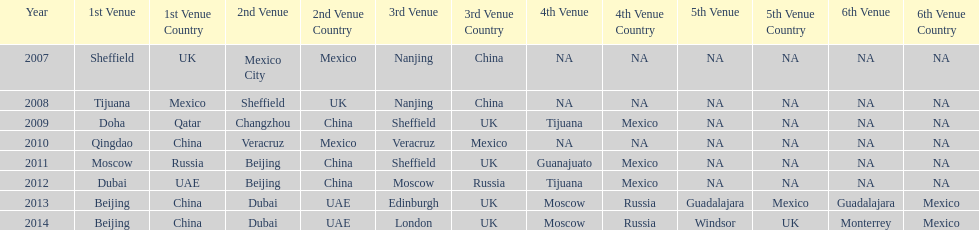Could you parse the entire table? {'header': ['Year', '1st Venue', '1st Venue Country', '2nd Venue', '2nd Venue Country', '3rd Venue', '3rd Venue Country', '4th Venue', '4th Venue Country', '5th Venue', '5th Venue Country', '6th Venue', '6th Venue Country'], 'rows': [['2007', 'Sheffield', 'UK', 'Mexico City', 'Mexico', 'Nanjing', 'China', 'NA', 'NA', 'NA', 'NA', 'NA', 'NA'], ['2008', 'Tijuana', 'Mexico', 'Sheffield', 'UK', 'Nanjing', 'China', 'NA', 'NA', 'NA', 'NA', 'NA', 'NA'], ['2009', 'Doha', 'Qatar', 'Changzhou', 'China', 'Sheffield', 'UK', 'Tijuana', 'Mexico', 'NA', 'NA', 'NA', 'NA'], ['2010', 'Qingdao', 'China', 'Veracruz', 'Mexico', 'Veracruz', 'Mexico', 'NA', 'NA', 'NA', 'NA', 'NA', 'NA'], ['2011', 'Moscow', 'Russia', 'Beijing', 'China', 'Sheffield', 'UK', 'Guanajuato', 'Mexico', 'NA', 'NA', 'NA', 'NA'], ['2012', 'Dubai', 'UAE', 'Beijing', 'China', 'Moscow', 'Russia', 'Tijuana', 'Mexico', 'NA', 'NA', 'NA', 'NA'], ['2013', 'Beijing', 'China', 'Dubai', 'UAE', 'Edinburgh', 'UK', 'Moscow', 'Russia', 'Guadalajara', 'Mexico', 'Guadalajara', 'Mexico'], ['2014', 'Beijing', 'China', 'Dubai', 'UAE', 'London', 'UK', 'Moscow', 'Russia', 'Windsor', 'UK', 'Monterrey', 'Mexico']]} What was the last year where tijuana was a venue? 2012. 